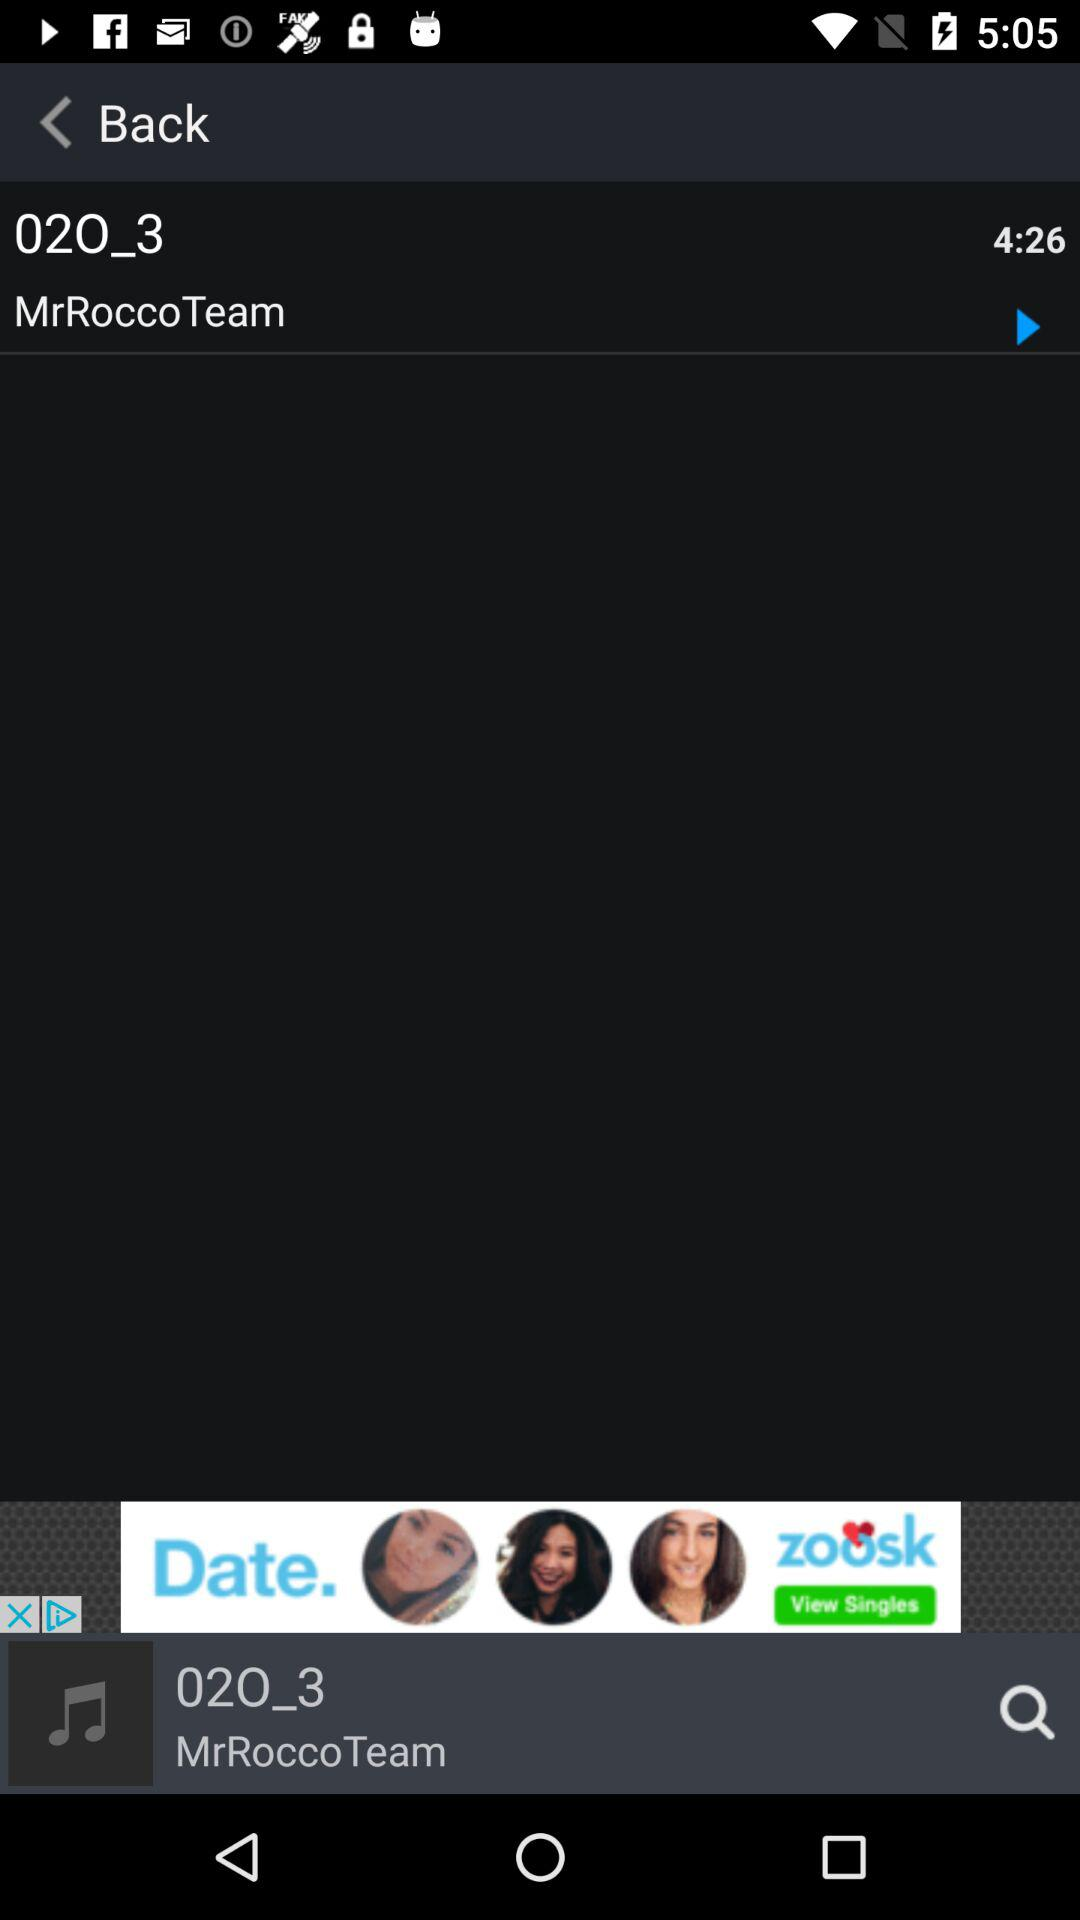What is the duration of the song? The duration is 4 minute and 26 seconds. 